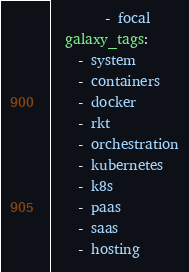<code> <loc_0><loc_0><loc_500><loc_500><_YAML_>        - focal
  galaxy_tags:
    - system
    - containers
    - docker
    - rkt
    - orchestration
    - kubernetes
    - k8s
    - paas
    - saas
    - hosting
</code> 